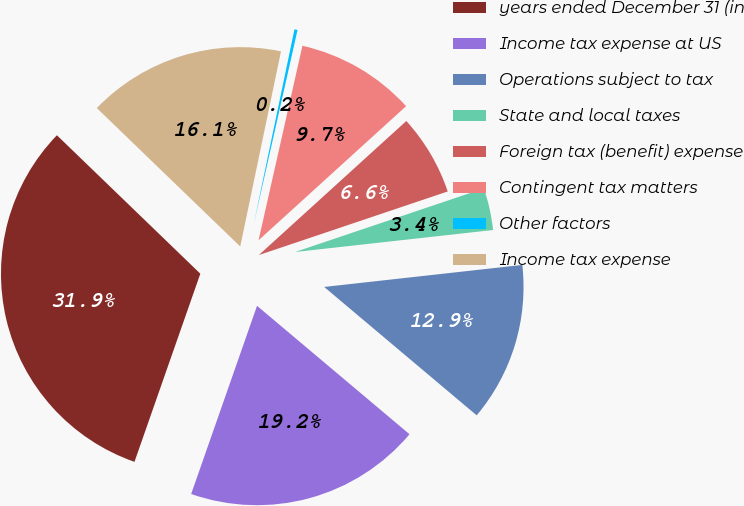<chart> <loc_0><loc_0><loc_500><loc_500><pie_chart><fcel>years ended December 31 (in<fcel>Income tax expense at US<fcel>Operations subject to tax<fcel>State and local taxes<fcel>Foreign tax (benefit) expense<fcel>Contingent tax matters<fcel>Other factors<fcel>Income tax expense<nl><fcel>31.86%<fcel>19.22%<fcel>12.9%<fcel>3.41%<fcel>6.57%<fcel>9.73%<fcel>0.25%<fcel>16.06%<nl></chart> 